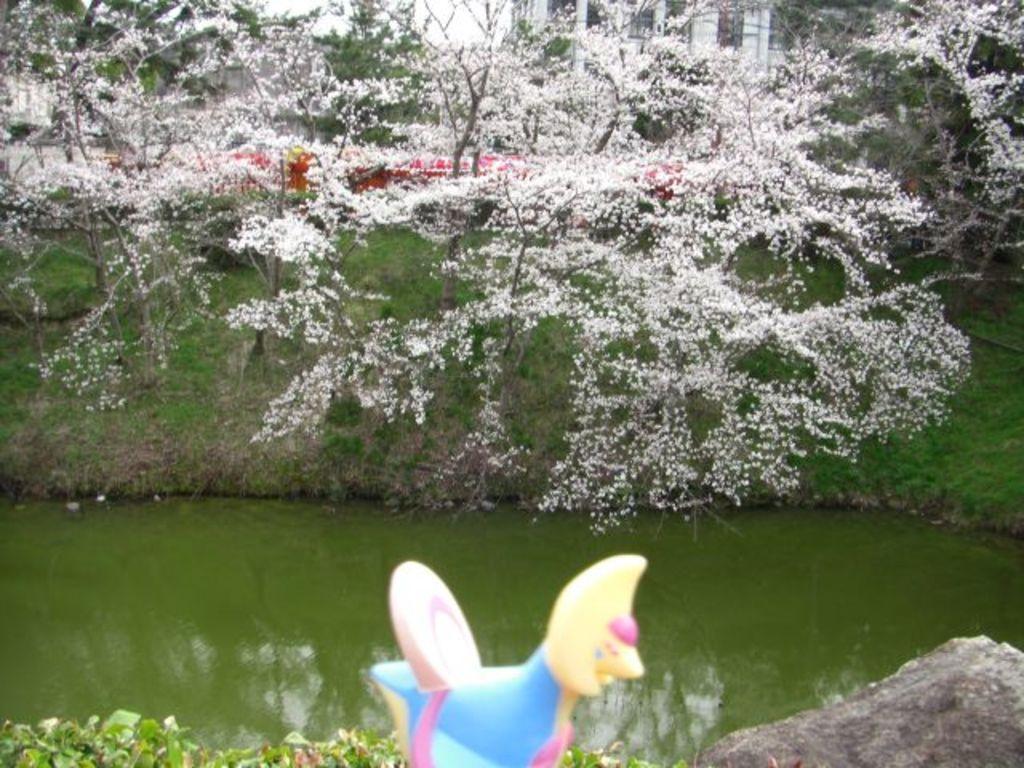In one or two sentences, can you explain what this image depicts? In this picture there is an object and there is water behind it and there are trees which has white flowers on it and there is a building in the background. 